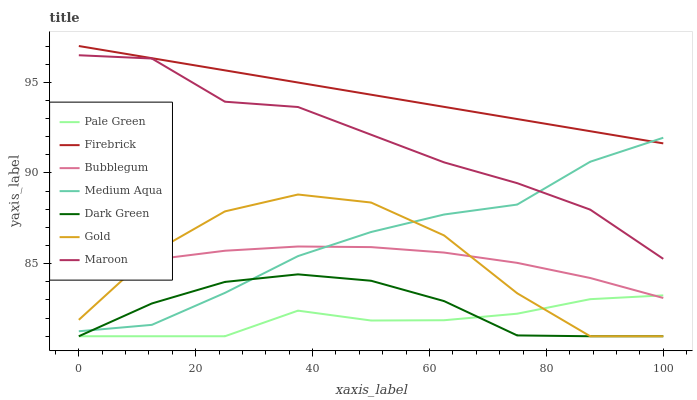Does Pale Green have the minimum area under the curve?
Answer yes or no. Yes. Does Firebrick have the maximum area under the curve?
Answer yes or no. Yes. Does Bubblegum have the minimum area under the curve?
Answer yes or no. No. Does Bubblegum have the maximum area under the curve?
Answer yes or no. No. Is Firebrick the smoothest?
Answer yes or no. Yes. Is Gold the roughest?
Answer yes or no. Yes. Is Bubblegum the smoothest?
Answer yes or no. No. Is Bubblegum the roughest?
Answer yes or no. No. Does Gold have the lowest value?
Answer yes or no. Yes. Does Bubblegum have the lowest value?
Answer yes or no. No. Does Firebrick have the highest value?
Answer yes or no. Yes. Does Bubblegum have the highest value?
Answer yes or no. No. Is Dark Green less than Bubblegum?
Answer yes or no. Yes. Is Maroon greater than Bubblegum?
Answer yes or no. Yes. Does Medium Aqua intersect Bubblegum?
Answer yes or no. Yes. Is Medium Aqua less than Bubblegum?
Answer yes or no. No. Is Medium Aqua greater than Bubblegum?
Answer yes or no. No. Does Dark Green intersect Bubblegum?
Answer yes or no. No. 